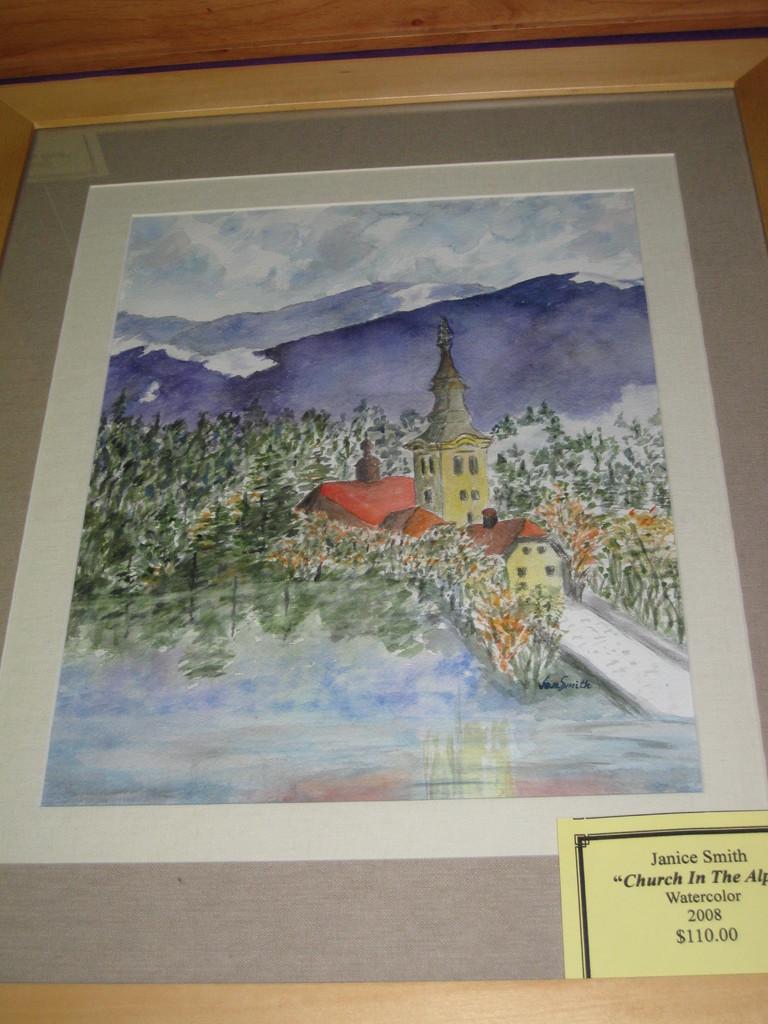What is the value of the painting?
Keep it short and to the point. $110.00. Who is the artist of the painting?
Your answer should be compact. Janice smith. 